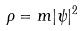Convert formula to latex. <formula><loc_0><loc_0><loc_500><loc_500>\rho = m | \psi | ^ { 2 }</formula> 